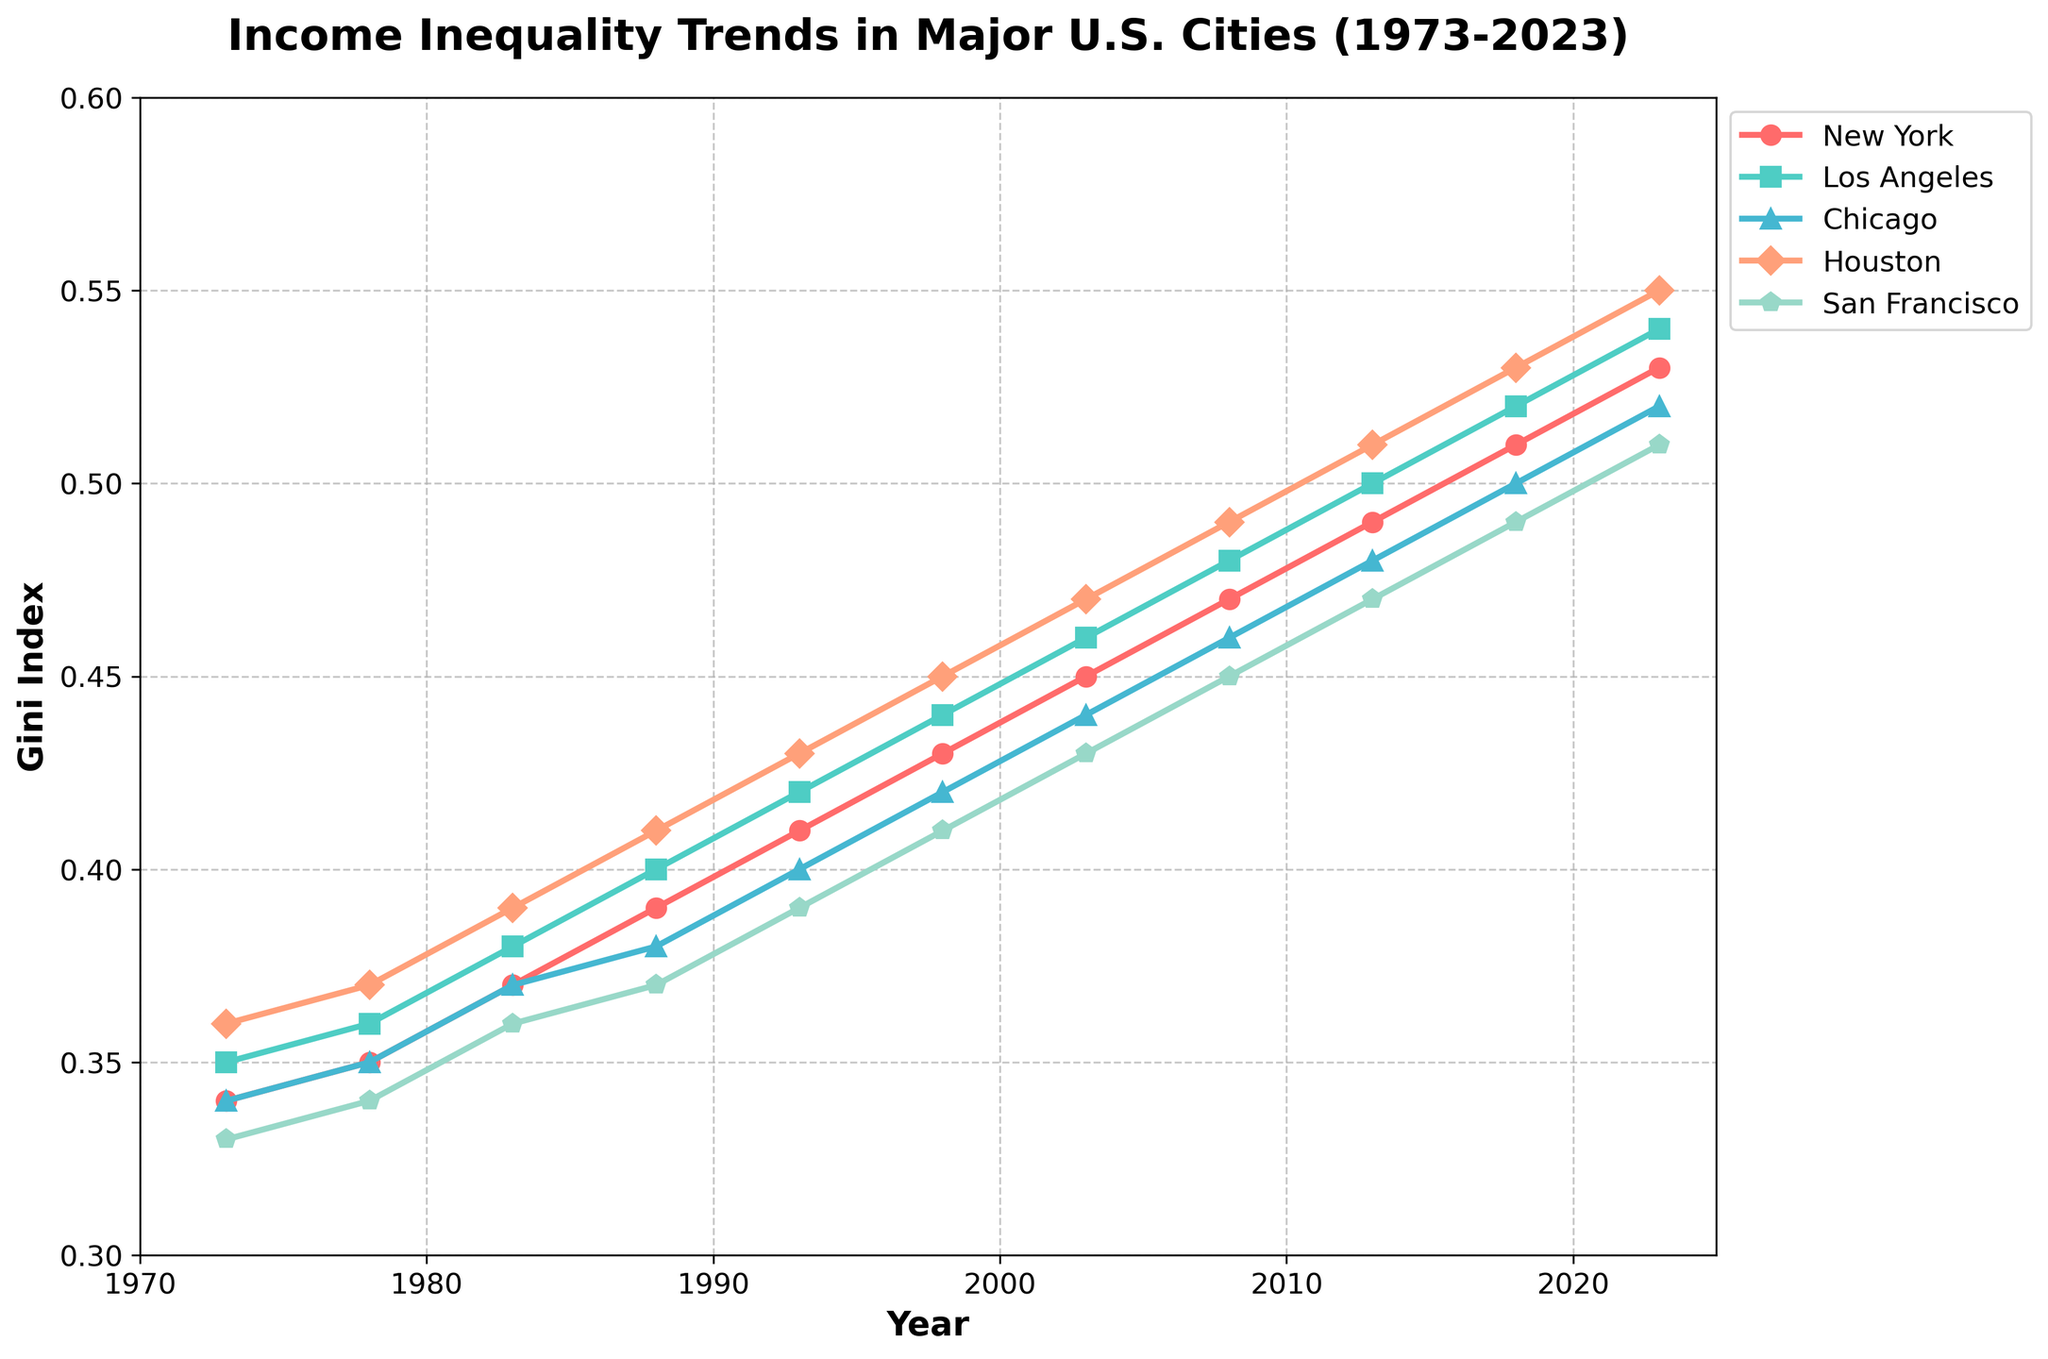What's the general trend in income inequality for New York between 1973 and 2023? Observing the plot, the Gini Index for New York shows a clear upward trend from 0.34 in 1973 to 0.53 in 2023. This indicates that income inequality has increased over the past 50 years.
Answer: An upward trend Which city had the highest Gini Index in 2023? From the plot, Houston has the highest Gini Index in 2023, reaching 0.55.
Answer: Houston What is the difference in the Gini Index between Los Angeles and Chicago in 2013? According to the plot, the Gini Index for Los Angeles in 2013 is 0.50, and for Chicago, it is 0.48. The difference between them is 0.50 - 0.48 = 0.02.
Answer: 0.02 How does the income inequality trend in San Francisco compare to that in Houston over the 50 years? Both cities show an increasing trend in income inequality. However, Houston's Gini Index increased from 0.36 to 0.55, which is a larger increase compared to San Francisco, which went from 0.33 to 0.51. This indicates Houston experienced a steeper increase in income inequality.
Answer: Houston had a steeper increase Which year shows the highest increase in Gini Index for Chicago? To find the year with the highest increase, look for the steepest slope in the time series line for Chicago. The largest visible increase appears between 2008 and 2013, where the Gini Index rises from 0.46 to 0.48, an increase of 0.02.
Answer: Between 2008 and 2013 On average, which city has experienced the smallest increase in its Gini Index over the 50-year period? Calculate the increase for each city from 1973 to 2023: 
- New York: 0.53 - 0.34 = 0.19
- Los Angeles: 0.54 - 0.35 = 0.19
- Chicago: 0.52 - 0.34 = 0.18
- Houston: 0.55 - 0.36 = 0.19
- San Francisco: 0.51 - 0.33 = 0.18
Both Chicago and San Francisco have the smallest increase of 0.18.
Answer: Chicago and San Francisco In which decade did New York see the most significant jump in its Gini Index? Look at the changes in New York's Gini Index for each decade. The largest jump occurred between 2003 (0.45) and 2013 (0.49), an increase of 0.04.
Answer: 2000s What was the Gini Index for Houston in 1983, and how does it compare to the Gini Index for Los Angeles in the same year? In 1983, Houston's Gini Index was 0.39, and Los Angeles had a Gini Index of 0.38. Therefore, Houston's Gini Index was 0.01 higher than that of Los Angeles.
Answer: Houston’s was 0.01 higher Which city had the most consistent increase in the Gini Index without any fluctuations? By visually examining the plot, New York's Gini Index appears most consistent, showing a steady increase without noticeable fluctuations over the 50 years.
Answer: New York What is the average Gini Index for San Francisco over the entire period? To find the average Gini Index for San Francisco over the 50 years, sum the values and divide by the number of data points: (0.33+0.34+0.36+0.37+0.39+0.41+0.43+0.45+0.47+0.49+0.51)/11 ≈ 0.409.
Answer: ≈ 0.409 